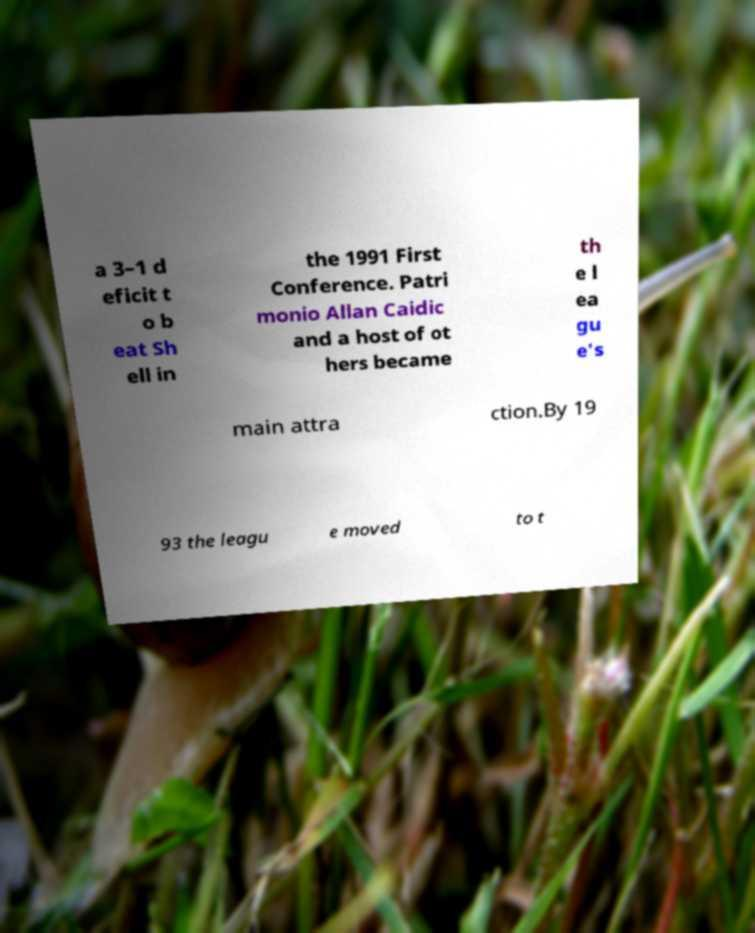Please identify and transcribe the text found in this image. a 3–1 d eficit t o b eat Sh ell in the 1991 First Conference. Patri monio Allan Caidic and a host of ot hers became th e l ea gu e's main attra ction.By 19 93 the leagu e moved to t 